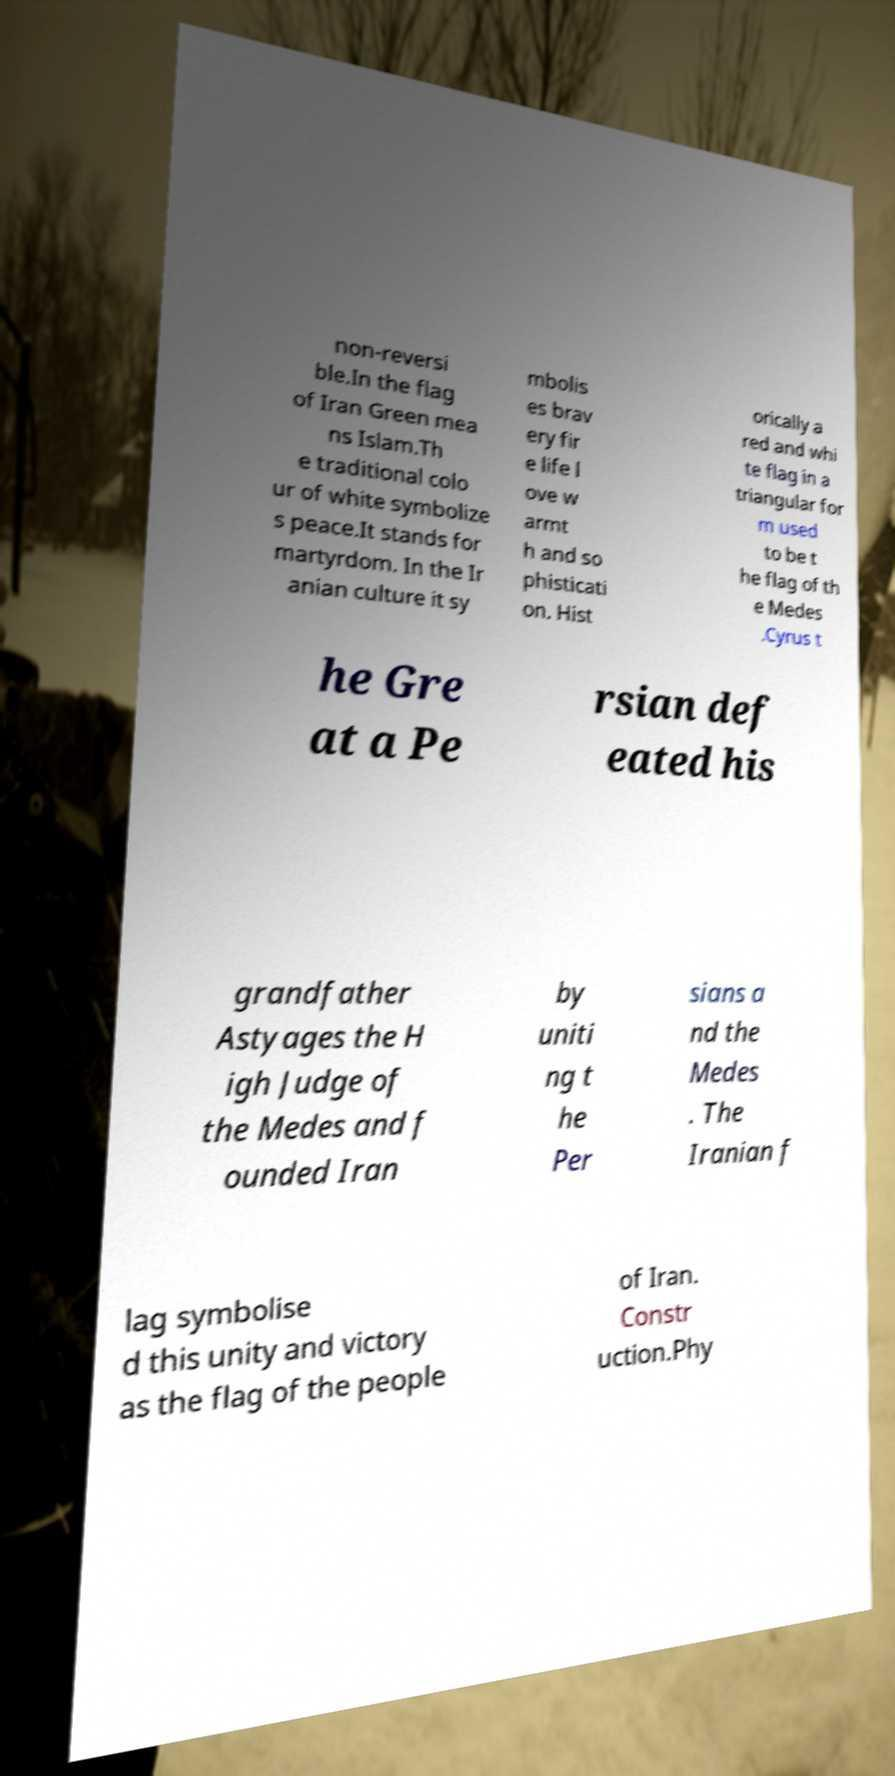Please read and relay the text visible in this image. What does it say? non-reversi ble.In the flag of Iran Green mea ns Islam.Th e traditional colo ur of white symbolize s peace.It stands for martyrdom. In the Ir anian culture it sy mbolis es brav ery fir e life l ove w armt h and so phisticati on. Hist orically a red and whi te flag in a triangular for m used to be t he flag of th e Medes .Cyrus t he Gre at a Pe rsian def eated his grandfather Astyages the H igh Judge of the Medes and f ounded Iran by uniti ng t he Per sians a nd the Medes . The Iranian f lag symbolise d this unity and victory as the flag of the people of Iran. Constr uction.Phy 